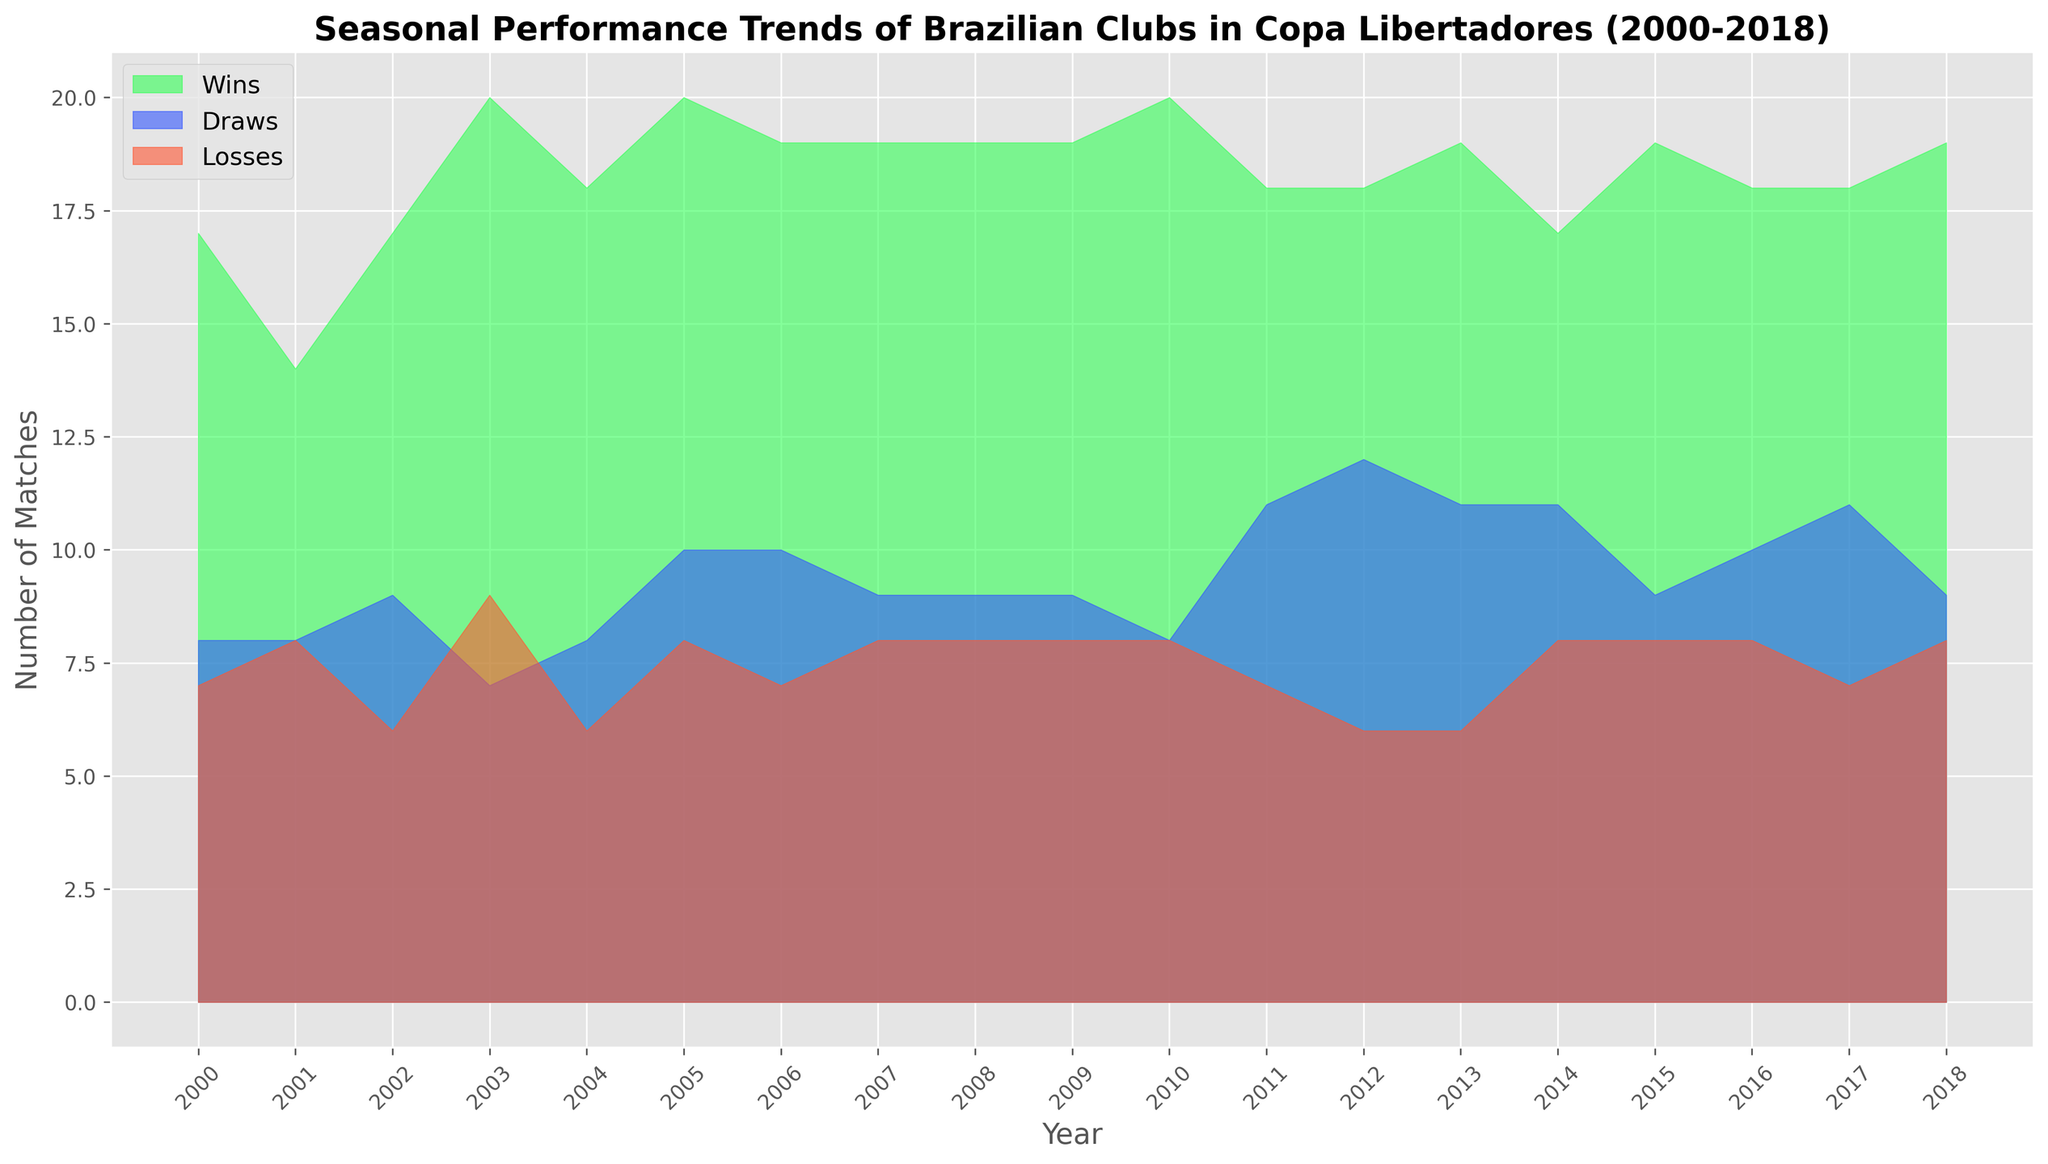Which year had the highest number of matches won? By looking at the areas under the green color (representing Wins) across all years, the peak is around the year with the highest value on the vertical axis.
Answer: 2005 How did the trend of draws change from 2000 to 2018? Analyze the blue areas (representing Draws) from 2000 to 2018. Identify the initial increase, the peaks, and any declines in between.
Answer: Initially increased, then fluctuated Which year shows the smallest difference between wins and losses? To calculate this, observe the peaks of the green areas (Wins) and red areas (Losses) for each year. The year with the smallest vertical distance between these areas will have the smallest difference.
Answer: 2011 Do wins generally trend together with goals for? Wins are represented by green areas. If these areas show a pattern similar to that of a team's goals for (historically high in certain years), we can infer a general trend relation.
Answer: Yes Which year had the lowest number of losses? Look for the year with the smallest area under the red color (Losses). The year with the smallest red area represents the lowest number of losses.
Answer: 2012 